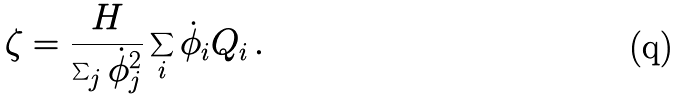Convert formula to latex. <formula><loc_0><loc_0><loc_500><loc_500>\zeta = \frac { H } { \sum _ { j } { \dot { \phi } _ { j } } ^ { 2 } } \sum _ { i } \dot { \phi } _ { i } Q _ { i } \, .</formula> 